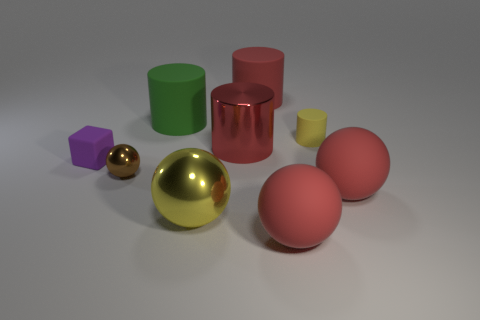Is there a sphere of the same color as the small cylinder?
Ensure brevity in your answer.  Yes. How many purple blocks are behind the tiny yellow cylinder that is right of the brown metallic sphere?
Keep it short and to the point. 0. There is a tiny rubber thing that is on the right side of the small sphere that is in front of the small matte thing in front of the small matte cylinder; what is its shape?
Give a very brief answer. Cylinder. What is the size of the rubber cylinder that is the same color as the big shiny cylinder?
Offer a terse response. Large. How many things are large red rubber cylinders or large yellow objects?
Ensure brevity in your answer.  2. The metal thing that is the same size as the red shiny cylinder is what color?
Provide a short and direct response. Yellow. There is a tiny yellow rubber thing; is it the same shape as the red object on the left side of the big red matte cylinder?
Provide a short and direct response. Yes. How many things are big red things that are in front of the large yellow sphere or things in front of the large yellow object?
Offer a very short reply. 1. There is a tiny rubber object that is the same color as the large metal ball; what shape is it?
Keep it short and to the point. Cylinder. There is a yellow object behind the tiny purple cube; what is its shape?
Ensure brevity in your answer.  Cylinder. 